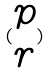Convert formula to latex. <formula><loc_0><loc_0><loc_500><loc_500>( \begin{matrix} p \\ r \end{matrix} )</formula> 